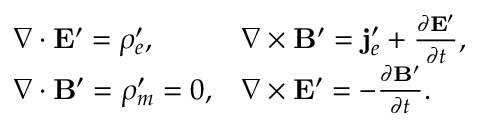Convert formula to latex. <formula><loc_0><loc_0><loc_500><loc_500>\begin{array} { l l } { { \nabla \cdot E ^ { \prime } = \rho _ { e } ^ { \prime } , } } & { { \nabla \times B ^ { \prime } = j _ { e } ^ { \prime } + \frac { \partial E ^ { \prime } } { \partial t } , } } \\ { { \nabla \cdot B ^ { \prime } = \rho _ { m } ^ { \prime } = 0 , } } & { { \nabla \times E ^ { \prime } = - \frac { \partial B ^ { \prime } } { \partial t } . } } \end{array}</formula> 